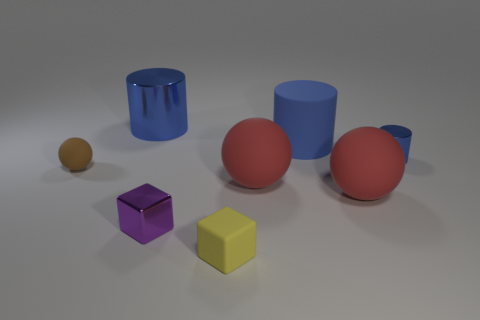There is a shiny object in front of the brown ball; is its size the same as the brown sphere? The shiny object appears to be smaller than the brown sphere when we compare their sizes visually. The reflective surface and the positioning may affect perception, but there is a noticeable size difference. 